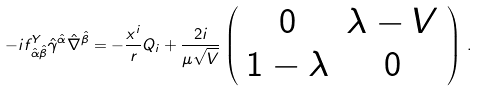Convert formula to latex. <formula><loc_0><loc_0><loc_500><loc_500>- i f ^ { Y } _ { \, \hat { \alpha } \hat { \beta } } \hat { \gamma } ^ { \hat { \alpha } } \hat { \nabla } ^ { \hat { \beta } } = - \frac { x ^ { i } } { r } Q _ { i } + \frac { 2 i } { \mu \sqrt { V } } \left ( \begin{array} { c c } 0 & \lambda - V \\ 1 - \lambda & 0 \end{array} \right ) \, .</formula> 